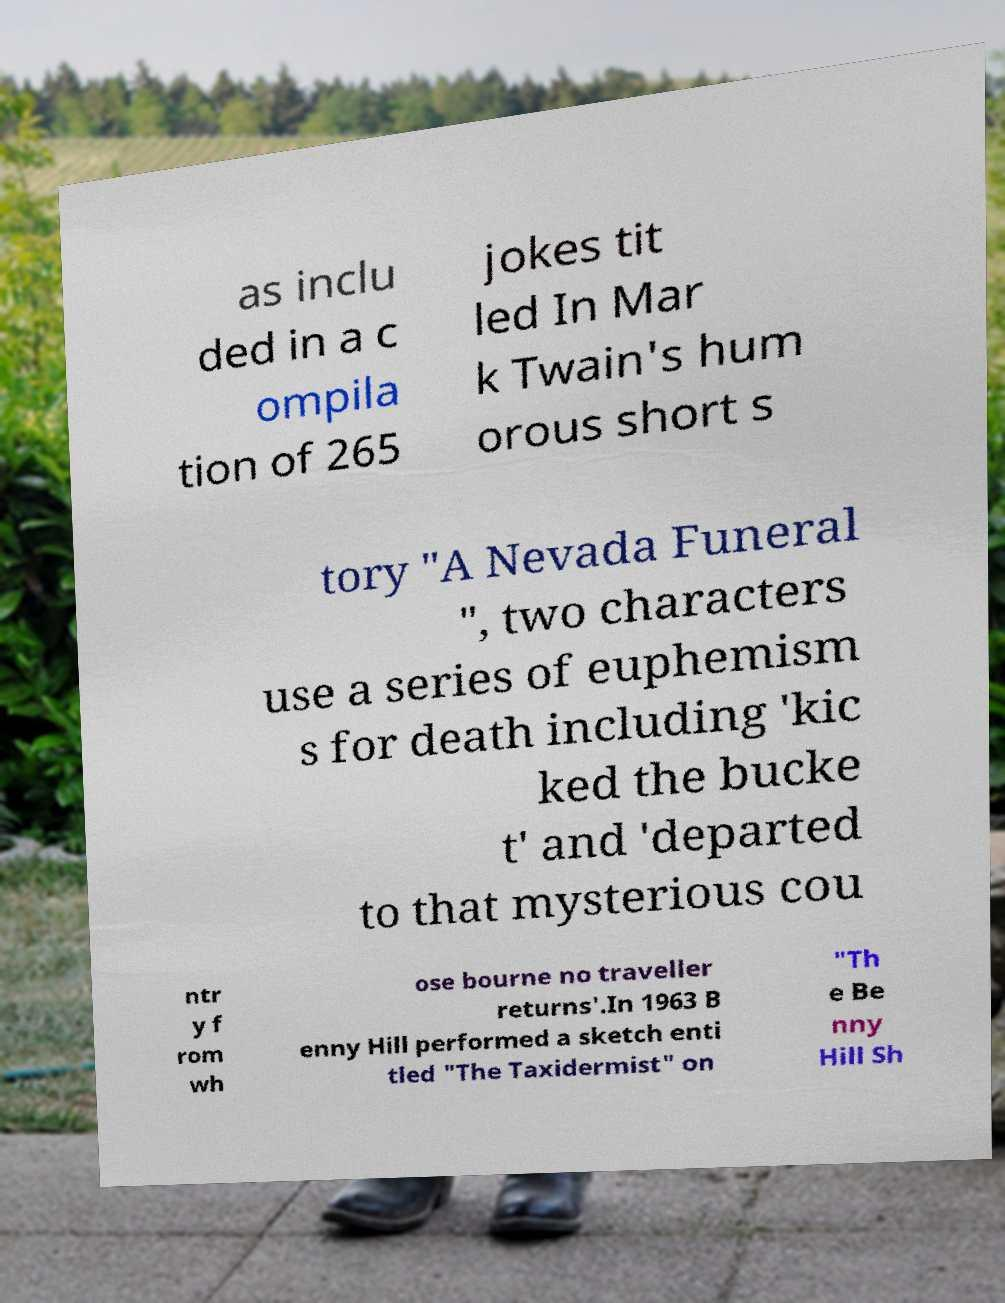What messages or text are displayed in this image? I need them in a readable, typed format. as inclu ded in a c ompila tion of 265 jokes tit led In Mar k Twain's hum orous short s tory "A Nevada Funeral ", two characters use a series of euphemism s for death including 'kic ked the bucke t' and 'departed to that mysterious cou ntr y f rom wh ose bourne no traveller returns'.In 1963 B enny Hill performed a sketch enti tled "The Taxidermist" on "Th e Be nny Hill Sh 